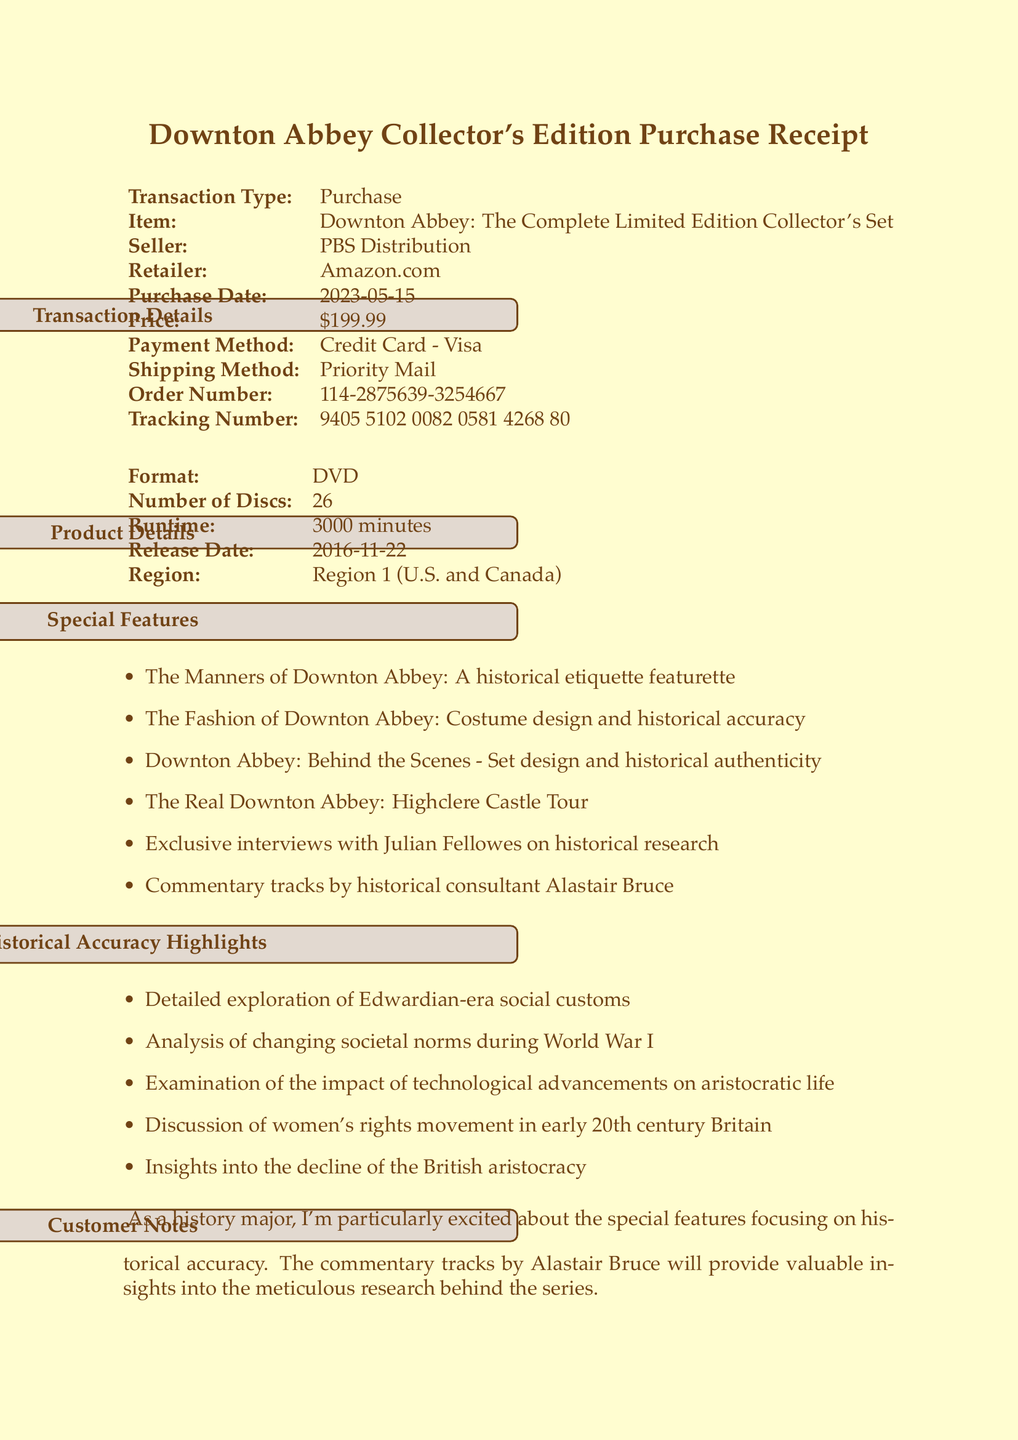What is the price of the collector's set? The price is stated in the transaction details section of the document.
Answer: $199.99 Who is the seller? The seller's name is provided in the transaction details of the document.
Answer: PBS Distribution When was the purchase made? The purchase date is included in the transaction details section.
Answer: 2023-05-15 How many discs are in the box set? The number of discs is specified in the product details section.
Answer: 26 What special feature focuses on historical etiquette? The special features list includes specific featurettes, one of which addresses this topic.
Answer: The Manners of Downton Abbey: A historical etiquette featurette Which consultant provided commentary tracks? The document mentions a specific historical consultant associated with the commentary tracks.
Answer: Alastair Bruce What is one historical accuracy highlight discussed in the document? Multiple highlights are listed in the section detailing historical accuracy.
Answer: Detailed exploration of Edwardian-era social customs What shipping method was used for this purchase? The shipping method is outlined in the transaction details.
Answer: Priority Mail What retailer was used for the purchase? The retailer's name is listed in the transaction details.
Answer: Amazon.com 